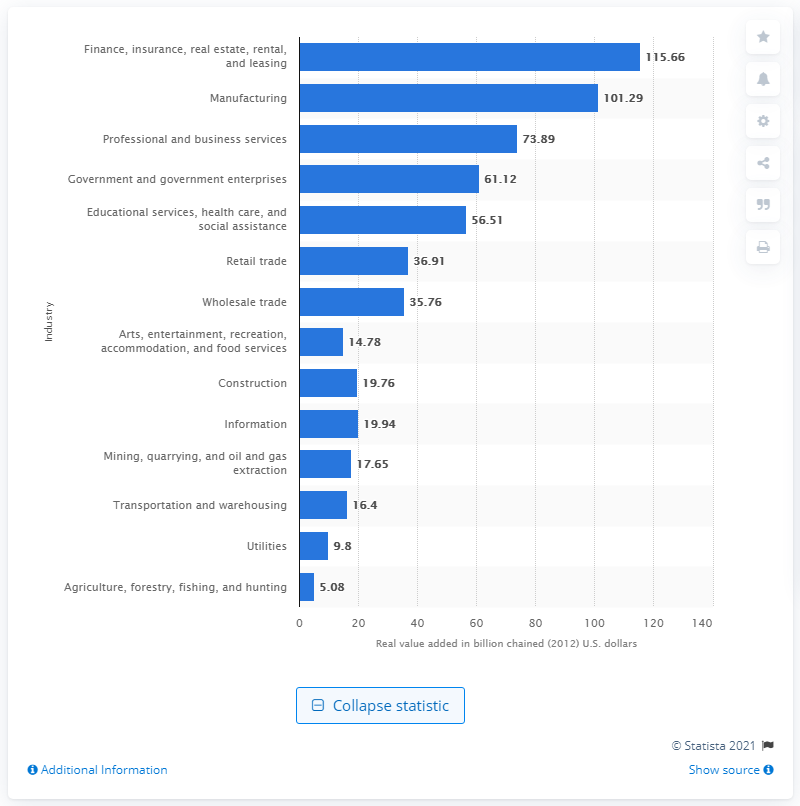Draw attention to some important aspects in this diagram. In 2012, the mining industry contributed 17.65 billion dollars to Ohio's gross domestic product. 